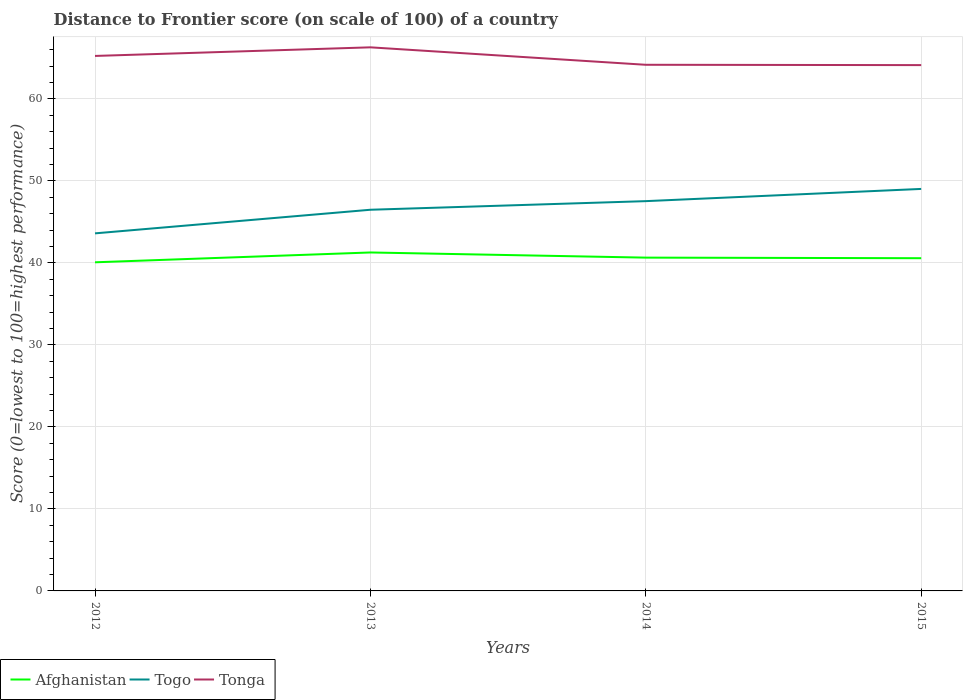Across all years, what is the maximum distance to frontier score of in Afghanistan?
Your response must be concise. 40.08. In which year was the distance to frontier score of in Afghanistan maximum?
Provide a short and direct response. 2012. What is the total distance to frontier score of in Tonga in the graph?
Give a very brief answer. -1.05. What is the difference between the highest and the second highest distance to frontier score of in Togo?
Keep it short and to the point. 5.42. What is the difference between the highest and the lowest distance to frontier score of in Togo?
Offer a very short reply. 2. Is the distance to frontier score of in Tonga strictly greater than the distance to frontier score of in Togo over the years?
Ensure brevity in your answer.  No. How many years are there in the graph?
Your answer should be very brief. 4. How are the legend labels stacked?
Make the answer very short. Horizontal. What is the title of the graph?
Provide a succinct answer. Distance to Frontier score (on scale of 100) of a country. What is the label or title of the Y-axis?
Make the answer very short. Score (0=lowest to 100=highest performance). What is the Score (0=lowest to 100=highest performance) in Afghanistan in 2012?
Your answer should be very brief. 40.08. What is the Score (0=lowest to 100=highest performance) in Togo in 2012?
Give a very brief answer. 43.61. What is the Score (0=lowest to 100=highest performance) in Tonga in 2012?
Your answer should be compact. 65.25. What is the Score (0=lowest to 100=highest performance) of Afghanistan in 2013?
Provide a short and direct response. 41.28. What is the Score (0=lowest to 100=highest performance) of Togo in 2013?
Make the answer very short. 46.49. What is the Score (0=lowest to 100=highest performance) in Tonga in 2013?
Provide a succinct answer. 66.3. What is the Score (0=lowest to 100=highest performance) in Afghanistan in 2014?
Provide a short and direct response. 40.65. What is the Score (0=lowest to 100=highest performance) of Togo in 2014?
Keep it short and to the point. 47.54. What is the Score (0=lowest to 100=highest performance) of Tonga in 2014?
Keep it short and to the point. 64.17. What is the Score (0=lowest to 100=highest performance) in Afghanistan in 2015?
Offer a very short reply. 40.58. What is the Score (0=lowest to 100=highest performance) of Togo in 2015?
Ensure brevity in your answer.  49.03. What is the Score (0=lowest to 100=highest performance) of Tonga in 2015?
Provide a succinct answer. 64.13. Across all years, what is the maximum Score (0=lowest to 100=highest performance) of Afghanistan?
Provide a short and direct response. 41.28. Across all years, what is the maximum Score (0=lowest to 100=highest performance) of Togo?
Provide a succinct answer. 49.03. Across all years, what is the maximum Score (0=lowest to 100=highest performance) in Tonga?
Offer a terse response. 66.3. Across all years, what is the minimum Score (0=lowest to 100=highest performance) of Afghanistan?
Make the answer very short. 40.08. Across all years, what is the minimum Score (0=lowest to 100=highest performance) in Togo?
Provide a succinct answer. 43.61. Across all years, what is the minimum Score (0=lowest to 100=highest performance) of Tonga?
Keep it short and to the point. 64.13. What is the total Score (0=lowest to 100=highest performance) in Afghanistan in the graph?
Your answer should be very brief. 162.59. What is the total Score (0=lowest to 100=highest performance) of Togo in the graph?
Offer a terse response. 186.67. What is the total Score (0=lowest to 100=highest performance) of Tonga in the graph?
Provide a succinct answer. 259.85. What is the difference between the Score (0=lowest to 100=highest performance) of Togo in 2012 and that in 2013?
Ensure brevity in your answer.  -2.88. What is the difference between the Score (0=lowest to 100=highest performance) in Tonga in 2012 and that in 2013?
Offer a terse response. -1.05. What is the difference between the Score (0=lowest to 100=highest performance) of Afghanistan in 2012 and that in 2014?
Your response must be concise. -0.57. What is the difference between the Score (0=lowest to 100=highest performance) in Togo in 2012 and that in 2014?
Give a very brief answer. -3.93. What is the difference between the Score (0=lowest to 100=highest performance) in Afghanistan in 2012 and that in 2015?
Make the answer very short. -0.5. What is the difference between the Score (0=lowest to 100=highest performance) of Togo in 2012 and that in 2015?
Offer a terse response. -5.42. What is the difference between the Score (0=lowest to 100=highest performance) of Tonga in 2012 and that in 2015?
Offer a terse response. 1.12. What is the difference between the Score (0=lowest to 100=highest performance) in Afghanistan in 2013 and that in 2014?
Give a very brief answer. 0.63. What is the difference between the Score (0=lowest to 100=highest performance) of Togo in 2013 and that in 2014?
Give a very brief answer. -1.05. What is the difference between the Score (0=lowest to 100=highest performance) in Tonga in 2013 and that in 2014?
Your response must be concise. 2.13. What is the difference between the Score (0=lowest to 100=highest performance) of Togo in 2013 and that in 2015?
Give a very brief answer. -2.54. What is the difference between the Score (0=lowest to 100=highest performance) in Tonga in 2013 and that in 2015?
Offer a terse response. 2.17. What is the difference between the Score (0=lowest to 100=highest performance) in Afghanistan in 2014 and that in 2015?
Make the answer very short. 0.07. What is the difference between the Score (0=lowest to 100=highest performance) in Togo in 2014 and that in 2015?
Give a very brief answer. -1.49. What is the difference between the Score (0=lowest to 100=highest performance) in Afghanistan in 2012 and the Score (0=lowest to 100=highest performance) in Togo in 2013?
Make the answer very short. -6.41. What is the difference between the Score (0=lowest to 100=highest performance) of Afghanistan in 2012 and the Score (0=lowest to 100=highest performance) of Tonga in 2013?
Offer a very short reply. -26.22. What is the difference between the Score (0=lowest to 100=highest performance) in Togo in 2012 and the Score (0=lowest to 100=highest performance) in Tonga in 2013?
Ensure brevity in your answer.  -22.69. What is the difference between the Score (0=lowest to 100=highest performance) of Afghanistan in 2012 and the Score (0=lowest to 100=highest performance) of Togo in 2014?
Keep it short and to the point. -7.46. What is the difference between the Score (0=lowest to 100=highest performance) of Afghanistan in 2012 and the Score (0=lowest to 100=highest performance) of Tonga in 2014?
Provide a succinct answer. -24.09. What is the difference between the Score (0=lowest to 100=highest performance) of Togo in 2012 and the Score (0=lowest to 100=highest performance) of Tonga in 2014?
Give a very brief answer. -20.56. What is the difference between the Score (0=lowest to 100=highest performance) in Afghanistan in 2012 and the Score (0=lowest to 100=highest performance) in Togo in 2015?
Make the answer very short. -8.95. What is the difference between the Score (0=lowest to 100=highest performance) of Afghanistan in 2012 and the Score (0=lowest to 100=highest performance) of Tonga in 2015?
Provide a succinct answer. -24.05. What is the difference between the Score (0=lowest to 100=highest performance) of Togo in 2012 and the Score (0=lowest to 100=highest performance) of Tonga in 2015?
Offer a terse response. -20.52. What is the difference between the Score (0=lowest to 100=highest performance) of Afghanistan in 2013 and the Score (0=lowest to 100=highest performance) of Togo in 2014?
Ensure brevity in your answer.  -6.26. What is the difference between the Score (0=lowest to 100=highest performance) in Afghanistan in 2013 and the Score (0=lowest to 100=highest performance) in Tonga in 2014?
Your answer should be very brief. -22.89. What is the difference between the Score (0=lowest to 100=highest performance) of Togo in 2013 and the Score (0=lowest to 100=highest performance) of Tonga in 2014?
Offer a terse response. -17.68. What is the difference between the Score (0=lowest to 100=highest performance) of Afghanistan in 2013 and the Score (0=lowest to 100=highest performance) of Togo in 2015?
Your answer should be compact. -7.75. What is the difference between the Score (0=lowest to 100=highest performance) of Afghanistan in 2013 and the Score (0=lowest to 100=highest performance) of Tonga in 2015?
Provide a succinct answer. -22.85. What is the difference between the Score (0=lowest to 100=highest performance) of Togo in 2013 and the Score (0=lowest to 100=highest performance) of Tonga in 2015?
Make the answer very short. -17.64. What is the difference between the Score (0=lowest to 100=highest performance) of Afghanistan in 2014 and the Score (0=lowest to 100=highest performance) of Togo in 2015?
Your answer should be very brief. -8.38. What is the difference between the Score (0=lowest to 100=highest performance) in Afghanistan in 2014 and the Score (0=lowest to 100=highest performance) in Tonga in 2015?
Keep it short and to the point. -23.48. What is the difference between the Score (0=lowest to 100=highest performance) of Togo in 2014 and the Score (0=lowest to 100=highest performance) of Tonga in 2015?
Your answer should be very brief. -16.59. What is the average Score (0=lowest to 100=highest performance) of Afghanistan per year?
Your response must be concise. 40.65. What is the average Score (0=lowest to 100=highest performance) of Togo per year?
Offer a very short reply. 46.67. What is the average Score (0=lowest to 100=highest performance) in Tonga per year?
Make the answer very short. 64.96. In the year 2012, what is the difference between the Score (0=lowest to 100=highest performance) of Afghanistan and Score (0=lowest to 100=highest performance) of Togo?
Your response must be concise. -3.53. In the year 2012, what is the difference between the Score (0=lowest to 100=highest performance) in Afghanistan and Score (0=lowest to 100=highest performance) in Tonga?
Offer a terse response. -25.17. In the year 2012, what is the difference between the Score (0=lowest to 100=highest performance) of Togo and Score (0=lowest to 100=highest performance) of Tonga?
Keep it short and to the point. -21.64. In the year 2013, what is the difference between the Score (0=lowest to 100=highest performance) in Afghanistan and Score (0=lowest to 100=highest performance) in Togo?
Offer a terse response. -5.21. In the year 2013, what is the difference between the Score (0=lowest to 100=highest performance) of Afghanistan and Score (0=lowest to 100=highest performance) of Tonga?
Your answer should be compact. -25.02. In the year 2013, what is the difference between the Score (0=lowest to 100=highest performance) of Togo and Score (0=lowest to 100=highest performance) of Tonga?
Keep it short and to the point. -19.81. In the year 2014, what is the difference between the Score (0=lowest to 100=highest performance) of Afghanistan and Score (0=lowest to 100=highest performance) of Togo?
Give a very brief answer. -6.89. In the year 2014, what is the difference between the Score (0=lowest to 100=highest performance) in Afghanistan and Score (0=lowest to 100=highest performance) in Tonga?
Provide a short and direct response. -23.52. In the year 2014, what is the difference between the Score (0=lowest to 100=highest performance) in Togo and Score (0=lowest to 100=highest performance) in Tonga?
Provide a succinct answer. -16.63. In the year 2015, what is the difference between the Score (0=lowest to 100=highest performance) of Afghanistan and Score (0=lowest to 100=highest performance) of Togo?
Provide a succinct answer. -8.45. In the year 2015, what is the difference between the Score (0=lowest to 100=highest performance) of Afghanistan and Score (0=lowest to 100=highest performance) of Tonga?
Your response must be concise. -23.55. In the year 2015, what is the difference between the Score (0=lowest to 100=highest performance) in Togo and Score (0=lowest to 100=highest performance) in Tonga?
Ensure brevity in your answer.  -15.1. What is the ratio of the Score (0=lowest to 100=highest performance) in Afghanistan in 2012 to that in 2013?
Provide a short and direct response. 0.97. What is the ratio of the Score (0=lowest to 100=highest performance) in Togo in 2012 to that in 2013?
Your response must be concise. 0.94. What is the ratio of the Score (0=lowest to 100=highest performance) in Tonga in 2012 to that in 2013?
Provide a succinct answer. 0.98. What is the ratio of the Score (0=lowest to 100=highest performance) of Togo in 2012 to that in 2014?
Offer a terse response. 0.92. What is the ratio of the Score (0=lowest to 100=highest performance) of Tonga in 2012 to that in 2014?
Your answer should be compact. 1.02. What is the ratio of the Score (0=lowest to 100=highest performance) of Afghanistan in 2012 to that in 2015?
Ensure brevity in your answer.  0.99. What is the ratio of the Score (0=lowest to 100=highest performance) in Togo in 2012 to that in 2015?
Your response must be concise. 0.89. What is the ratio of the Score (0=lowest to 100=highest performance) of Tonga in 2012 to that in 2015?
Give a very brief answer. 1.02. What is the ratio of the Score (0=lowest to 100=highest performance) of Afghanistan in 2013 to that in 2014?
Provide a short and direct response. 1.02. What is the ratio of the Score (0=lowest to 100=highest performance) of Togo in 2013 to that in 2014?
Provide a succinct answer. 0.98. What is the ratio of the Score (0=lowest to 100=highest performance) in Tonga in 2013 to that in 2014?
Keep it short and to the point. 1.03. What is the ratio of the Score (0=lowest to 100=highest performance) in Afghanistan in 2013 to that in 2015?
Offer a very short reply. 1.02. What is the ratio of the Score (0=lowest to 100=highest performance) in Togo in 2013 to that in 2015?
Your answer should be compact. 0.95. What is the ratio of the Score (0=lowest to 100=highest performance) of Tonga in 2013 to that in 2015?
Offer a very short reply. 1.03. What is the ratio of the Score (0=lowest to 100=highest performance) in Togo in 2014 to that in 2015?
Keep it short and to the point. 0.97. What is the ratio of the Score (0=lowest to 100=highest performance) in Tonga in 2014 to that in 2015?
Provide a short and direct response. 1. What is the difference between the highest and the second highest Score (0=lowest to 100=highest performance) of Afghanistan?
Give a very brief answer. 0.63. What is the difference between the highest and the second highest Score (0=lowest to 100=highest performance) of Togo?
Offer a terse response. 1.49. What is the difference between the highest and the lowest Score (0=lowest to 100=highest performance) in Togo?
Your response must be concise. 5.42. What is the difference between the highest and the lowest Score (0=lowest to 100=highest performance) of Tonga?
Make the answer very short. 2.17. 